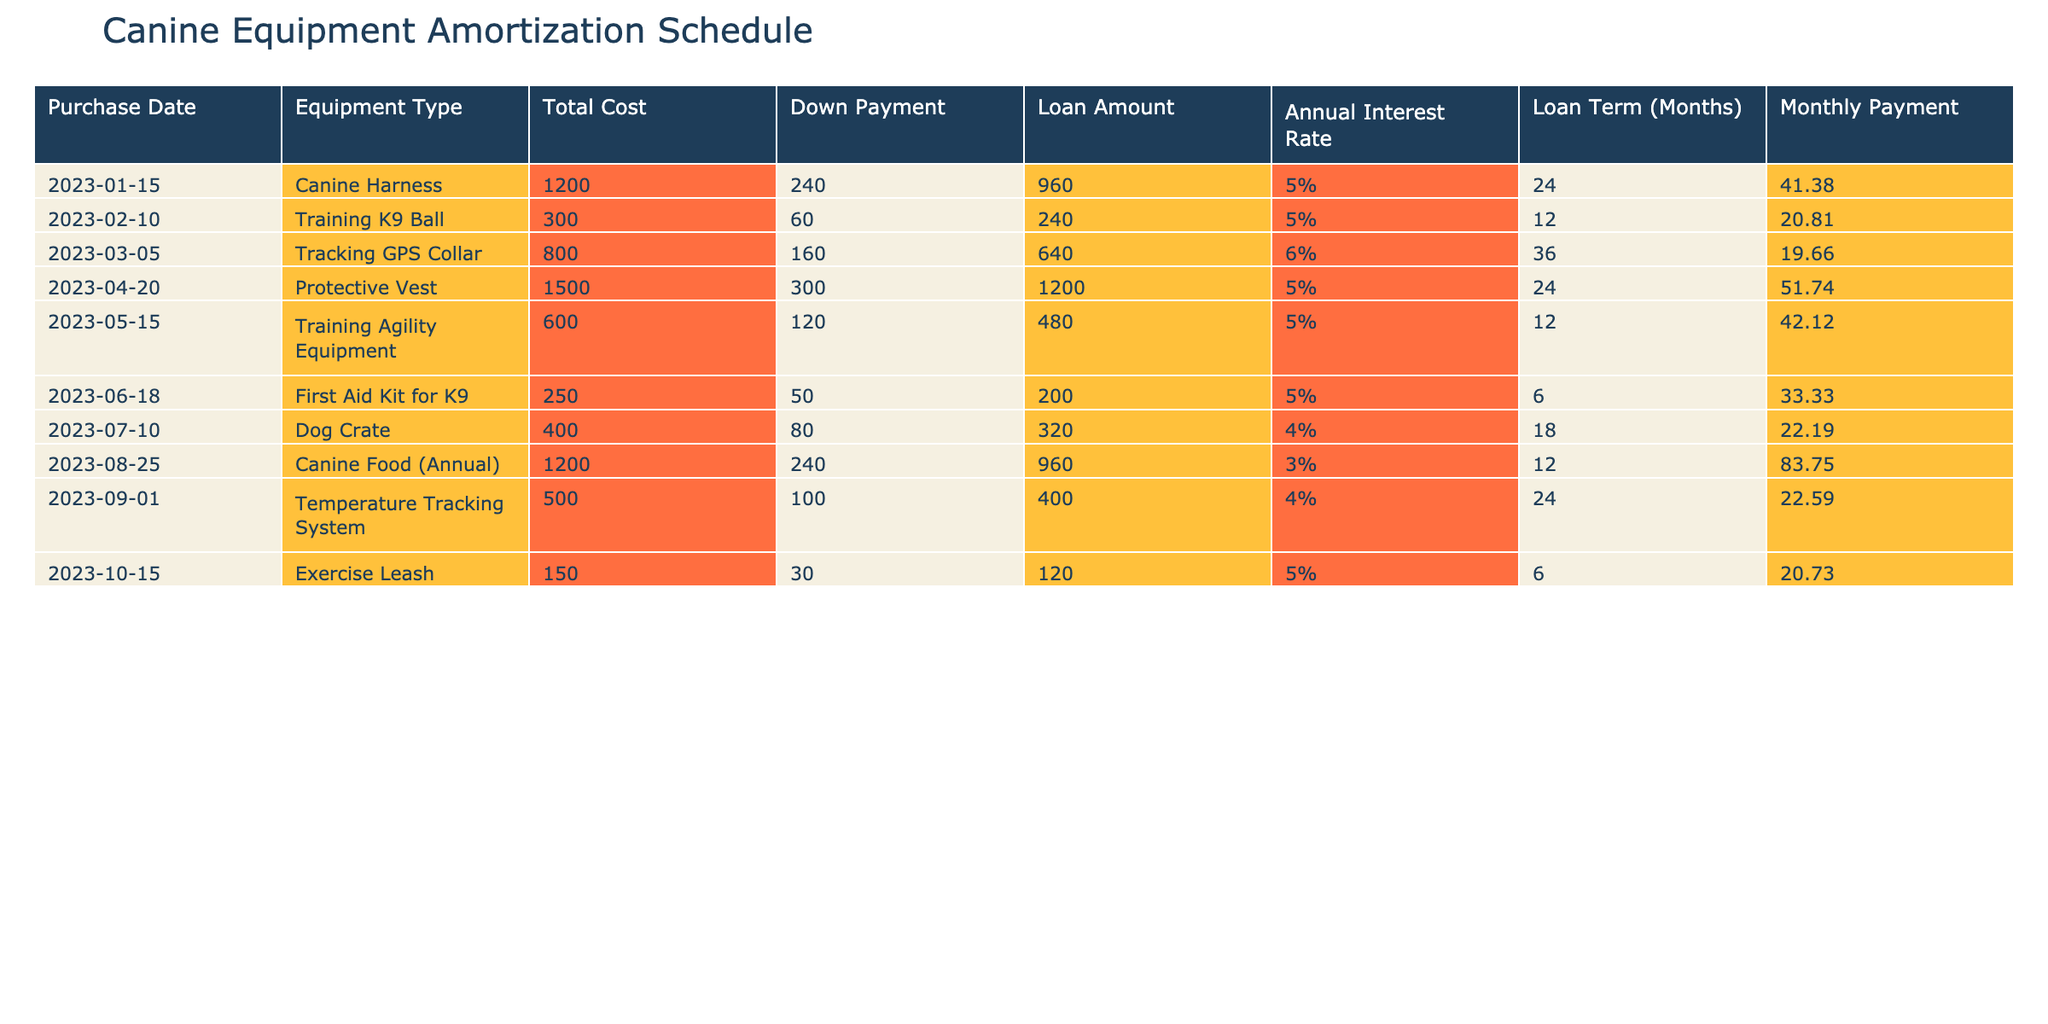What is the total cost of the Protective Vest? In the table, the row for the Protective Vest shows that its total cost is listed as 1500.
Answer: 1500 How much is the monthly payment for the First Aid Kit for K9? According to the row for the First Aid Kit for K9, the monthly payment is 33.33.
Answer: 33.33 What is the average loan amount for all equipment purchases? First, we sum the loan amounts: 960 + 240 + 640 + 1200 + 480 + 200 + 320 + 960 + 400 + 120 = 4720. Then we divide by the number of items, which is 10, resulting in an average of 472.
Answer: 472 Is the Annual Interest Rate for the Training K9 Ball higher than 5%? The Annual Interest Rate for the Training K9 Ball is 5%, so it is not higher than that.
Answer: No How many months is the loan term for the Tracking GPS Collar? The row corresponding to the Tracking GPS Collar indicates that the loan term is 36 months.
Answer: 36 What is the total monthly payment across all equipment purchases? We sum all the monthly payments: 41.38 + 20.81 + 19.66 + 51.74 + 42.12 + 33.33 + 22.19 + 83.75 + 22.59 + 20.73 =  345.56.
Answer: 345.56 Does the Dog Crate have a higher down payment than the Training Agility Equipment? The down payment for the Dog Crate is 80, while the Training Agility Equipment has a down payment of 120. Therefore, the Dog Crate does not have a higher down payment.
Answer: No Which equipment type has the highest monthly payment? We compare the monthly payments: 41.38, 20.81, 19.66, 51.74, 42.12, 33.33, 22.19, 83.75, 22.59, and 20.73. The highest payment is for the Canine Food (Annual) at 83.75.
Answer: Canine Food (Annual) How much more is the monthly payment for the Protective Vest compared to the monthly payment for the Dog Crate? The monthly payment for the Protective Vest is 51.74, and for the Dog Crate, it is 22.19. Subtracting gives us 51.74 - 22.19 = 29.55.
Answer: 29.55 